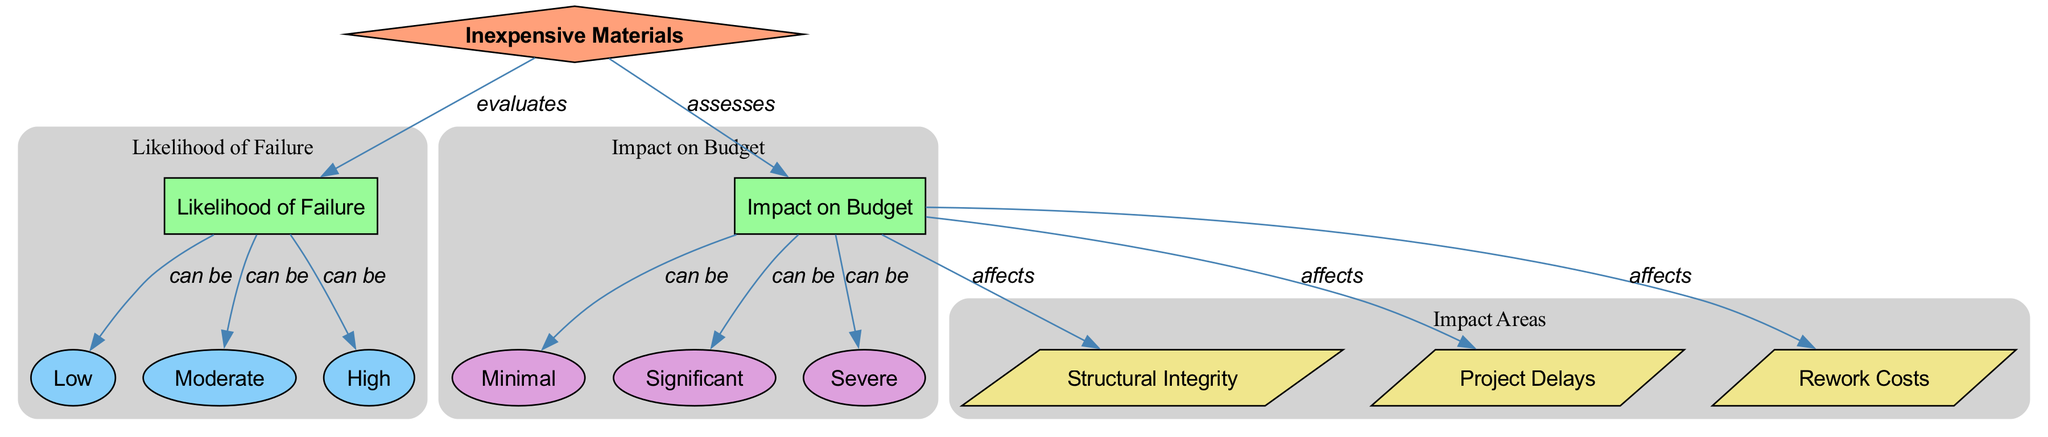What type of node represents “Inexpensive Materials”? The diagram categorizes nodes into types, where “Inexpensive Materials” is defined as a “decision” node. This is evident as it is the only node of that type and initiates the evaluation process shown in the diagram.
Answer: decision How many risk levels are identified in the diagram? The diagram presents three distinct risk levels under the category of “Likelihood of Failure”: Low, Moderate, and High. By counting these nodes, it's clear that there are three risk levels visually represented.
Answer: 3 Which impact level is associated with significant budget impact? The diagram identifies "Significant" as a specific impact level under the category of “Impact on Budget.” This node directly correlates to a substantial influence on overall budget considerations in the context of risky material usage.
Answer: Significant What area is affected by the budget's impact according to the diagram? The diagram links “Impact on Budget” to three specific areas: Structural Integrity, Project Delays, and Rework Costs. This indicates that the financial implications affect these critical aspects of construction management.
Answer: Structural Integrity, Project Delays, Rework Costs If the likelihood of failure is “High,” what budget impact level could it lead to? The diagram shows that a “High” likelihood of failure can be categorized into multiple impact levels. It suggests that the impact on the budget could potentially reach "Severe," indicating a major financial risk. Thus, the assumption is that higher likelihoods typically result in significant impacts.
Answer: Severe When assessing “Inexpensive Materials,” what does the diagram imply for project delays? According to the diagram, the assessment of “Inexpensive Materials” under the influence of “Impact on Budget” directly links to “Project Delays.” This relationship illustrates that selecting less costly materials may negatively affect the timeliness of project delivery.
Answer: Project Delays Which impact area is directly linked to the likelihood of failure? The diagram indicates that the “Impact on Budget” assessment has various affecting areas; it specifically mentions that both “Rework Costs” and “Project Delays” are affected by how likely failures are, thus establishing a direct link to those areas from the likelihood evaluation.
Answer: Rework Costs, Project Delays What is the visual representation type used for "Likelihood of Failure" in the diagram? The “Likelihood of Failure” is represented as a “category” type node, signified by the rectangle shape and light green color. This visual attribute differentiates it from other types such as risk levels and impact areas within the diagram.
Answer: category 